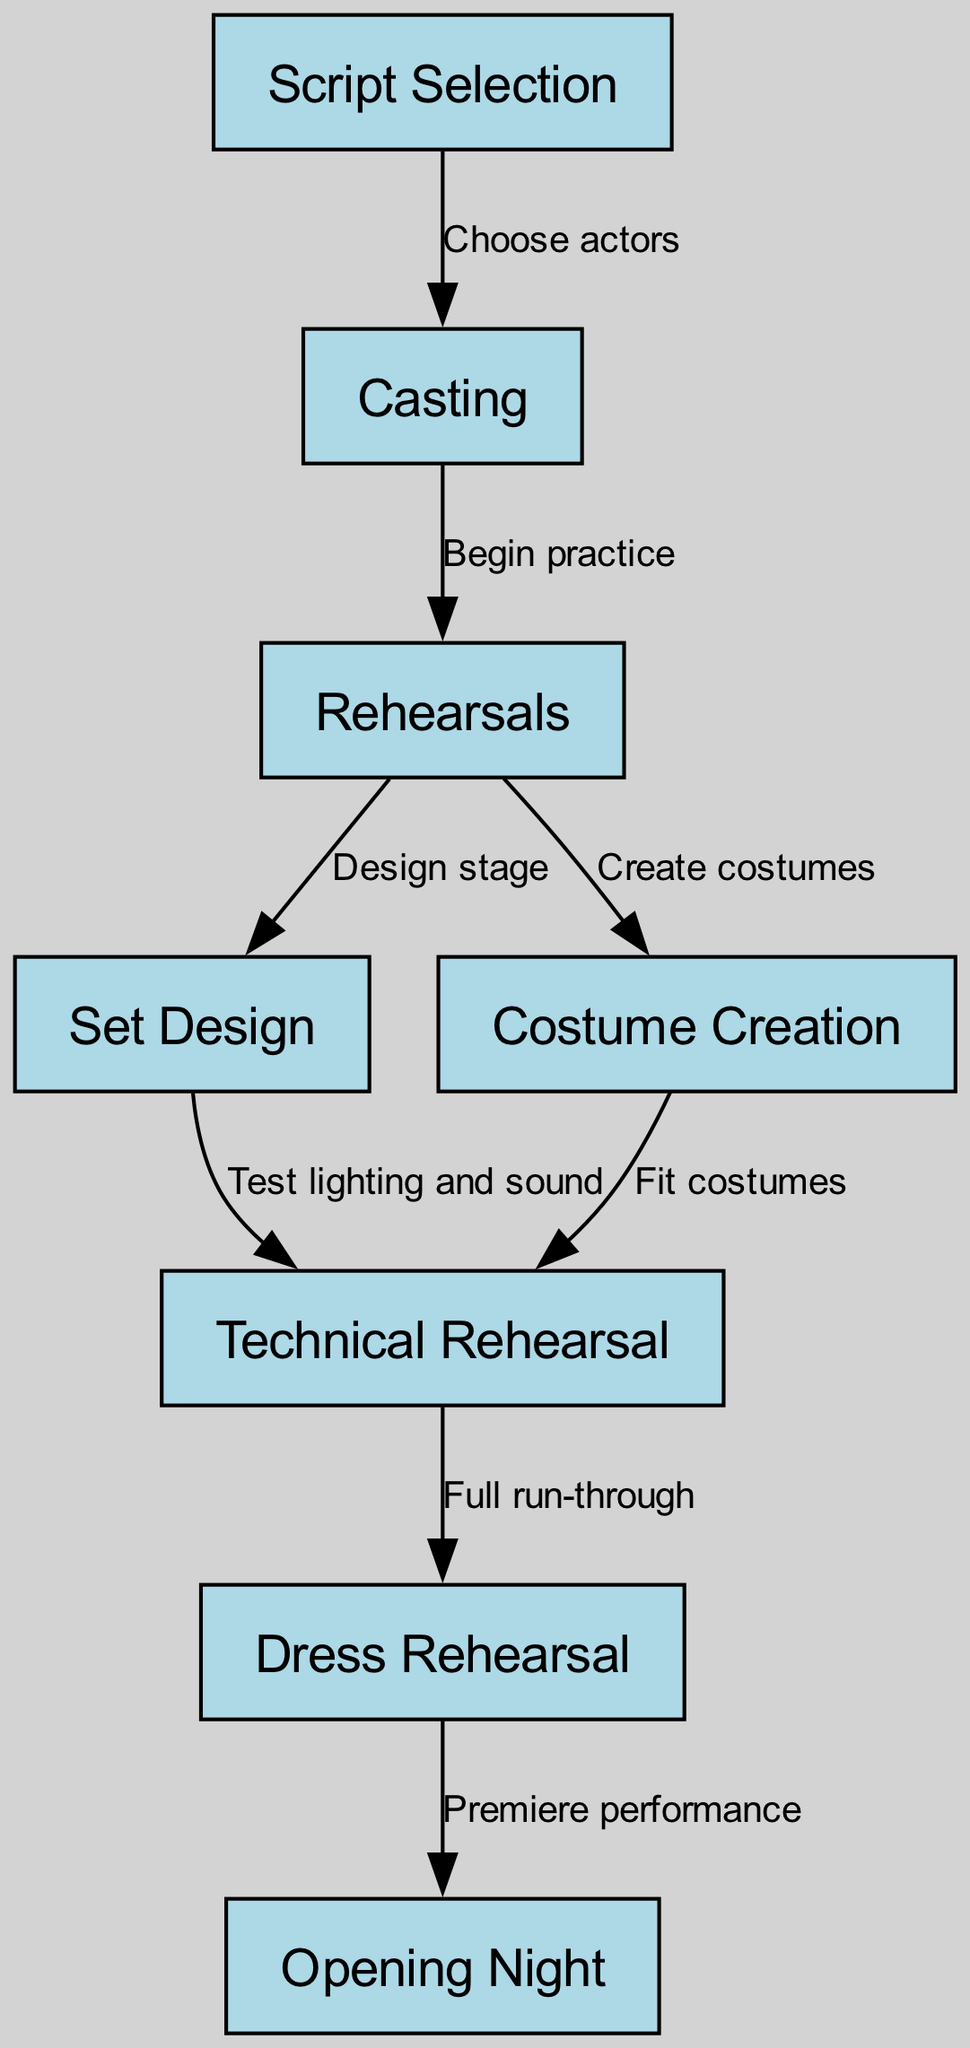what is the first step in the process depicted in the diagram? The first step in the flowchart is "Script Selection," which is the starting point of the play production process.
Answer: Script Selection how many nodes are present in the diagram? There are a total of 8 nodes in the diagram, representing different stages of the production process from script selection to opening night.
Answer: 8 which two nodes are connected by the edge labeled "Begin practice"? The edge labeled "Begin practice" connects the nodes "Casting" and "Rehearsals," indicating that after casting, rehearsals begin.
Answer: Casting and Rehearsals what is the last step before "Opening Night"? The last step before "Opening Night" is "Dress Rehearsal," which is a critical final rehearsal to prepare for the performance.
Answer: Dress Rehearsal which step involves fitting costumes? The step that involves fitting costumes is "Fit costumes," which follows the "Costume Creation" step in the process.
Answer: Fit costumes how many edges are there in the diagram? The diagram contains 7 edges, which describe the various transitions between each of the stages from script selection to opening night.
Answer: 7 what is the relationship between "Rehearsals" and "Set Design"? The relationship is that after "Rehearsals," the stage is designed, as indicated by the directed edge from "Rehearsals" to "Set Design."
Answer: Design stage what directly follows "Technical Rehearsal" in the diagram? "Dress Rehearsal" directly follows "Technical Rehearsal," indicating that after technical testing, a full dress rehearsal occurs before the performance.
Answer: Dress Rehearsal 